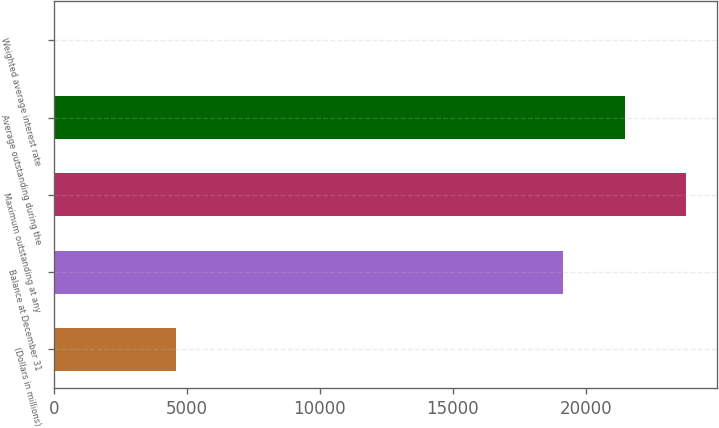<chart> <loc_0><loc_0><loc_500><loc_500><bar_chart><fcel>(Dollars in millions)<fcel>Balance at December 31<fcel>Maximum outstanding at any<fcel>Average outstanding during the<fcel>Weighted average interest rate<nl><fcel>4608.3<fcel>19147<fcel>23750.9<fcel>21449<fcel>4.38<nl></chart> 